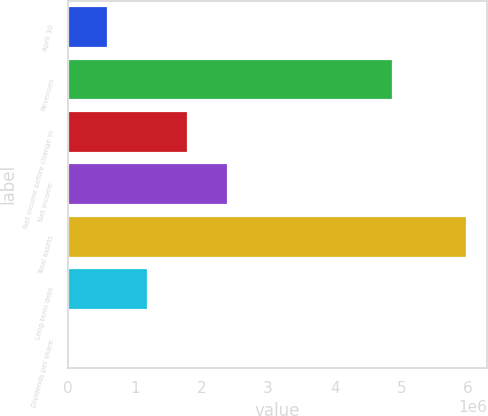Convert chart to OTSL. <chart><loc_0><loc_0><loc_500><loc_500><bar_chart><fcel>April 30<fcel>Revenues<fcel>Net income before change in<fcel>Net income<fcel>Total assets<fcel>Long-term debt<fcel>Dividends per share<nl><fcel>598914<fcel>4.8728e+06<fcel>1.79674e+06<fcel>2.39565e+06<fcel>5.98914e+06<fcel>1.19783e+06<fcel>0.49<nl></chart> 